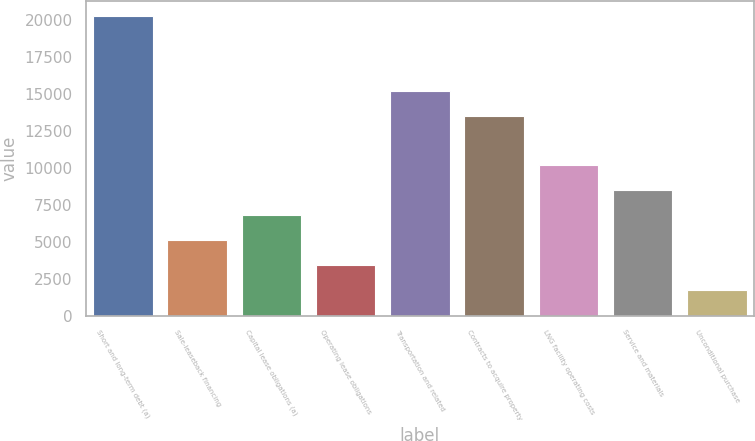Convert chart to OTSL. <chart><loc_0><loc_0><loc_500><loc_500><bar_chart><fcel>Short and long-term debt (a)<fcel>Sale-leaseback financing<fcel>Capital lease obligations (a)<fcel>Operating lease obligations<fcel>Transportation and related<fcel>Contracts to acquire property<fcel>LNG facility operating costs<fcel>Service and materials<fcel>Unconditional purchase<nl><fcel>20273.2<fcel>5084.8<fcel>6772.4<fcel>3397.2<fcel>15210.4<fcel>13522.8<fcel>10147.6<fcel>8460<fcel>1709.6<nl></chart> 